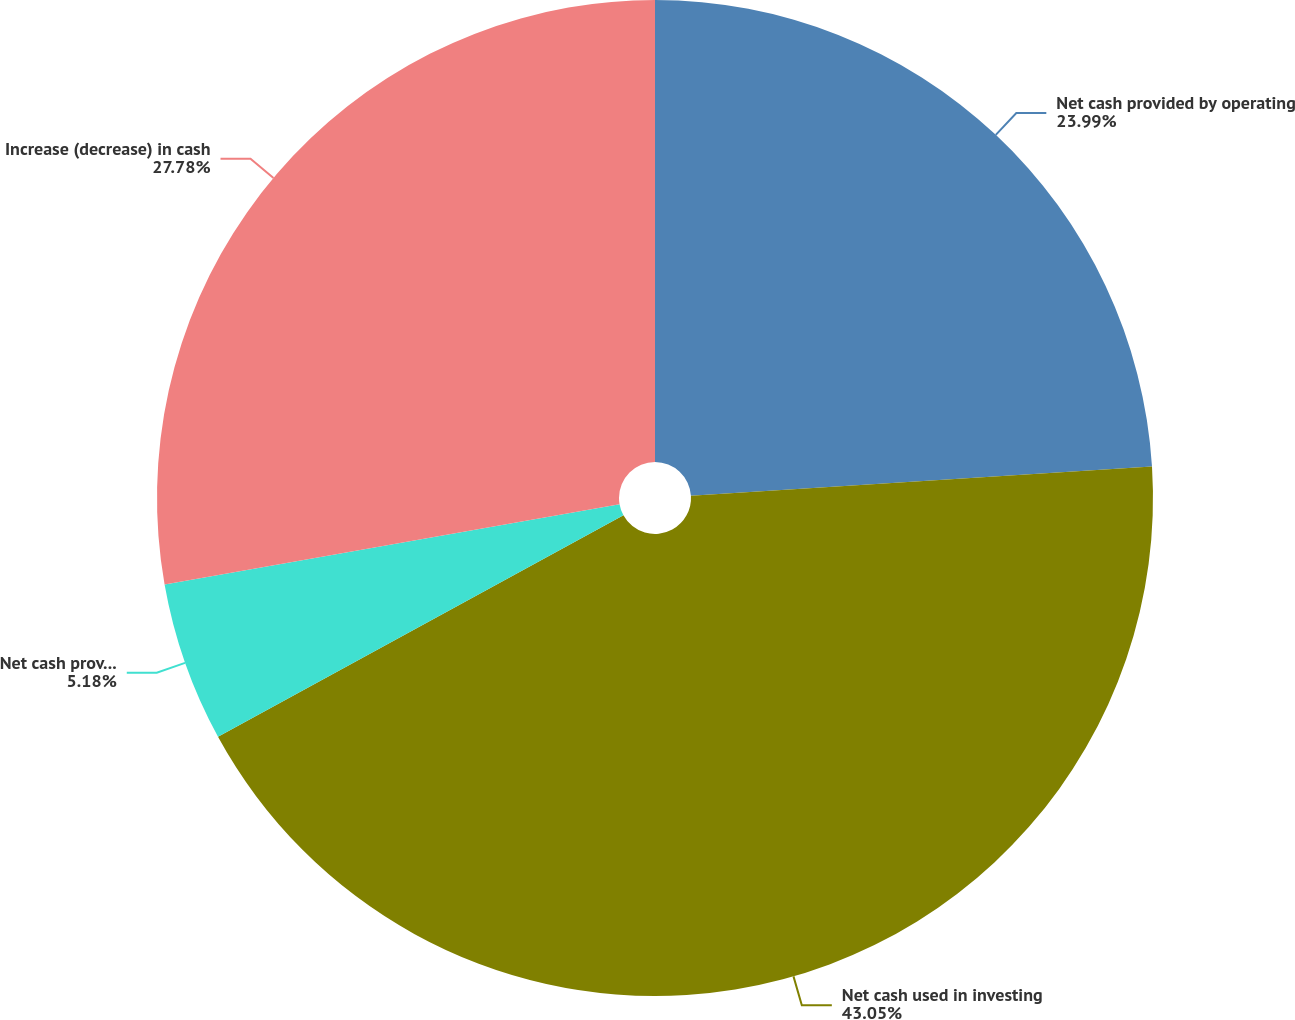Convert chart to OTSL. <chart><loc_0><loc_0><loc_500><loc_500><pie_chart><fcel>Net cash provided by operating<fcel>Net cash used in investing<fcel>Net cash provided by (used in)<fcel>Increase (decrease) in cash<nl><fcel>23.99%<fcel>43.05%<fcel>5.18%<fcel>27.78%<nl></chart> 